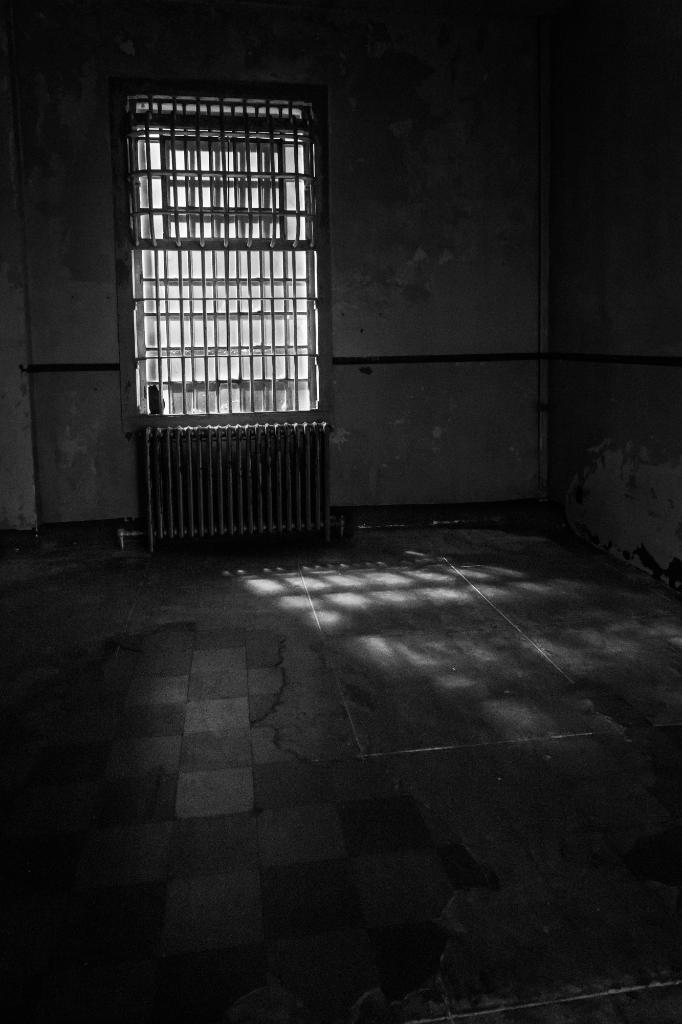What can be seen in the image that allows light to enter the room? There is a window in the image that allows sunlight to pass through. What is the wall made of in the image? The wall on the right side of the image is made of a solid material, but the specific material is not mentioned in the facts. How is the room being illuminated in the image? Sunlight is passing through the window, which illuminates the room. Are there any sticks hanging from the window in the image? There is no mention of sticks in the image, so it cannot be determined if any are present. 